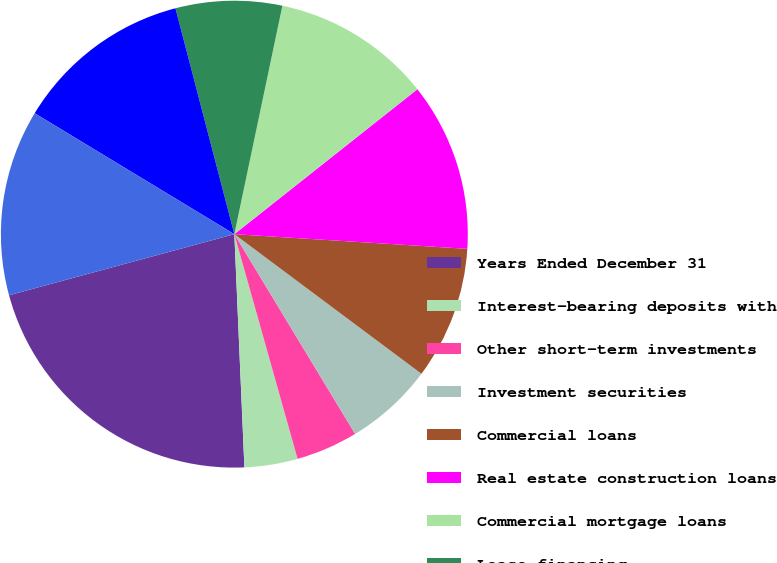Convert chart. <chart><loc_0><loc_0><loc_500><loc_500><pie_chart><fcel>Years Ended December 31<fcel>Interest-bearing deposits with<fcel>Other short-term investments<fcel>Investment securities<fcel>Commercial loans<fcel>Real estate construction loans<fcel>Commercial mortgage loans<fcel>Lease financing<fcel>International loans<fcel>Residential mortgage loans<nl><fcel>21.47%<fcel>3.68%<fcel>4.29%<fcel>6.14%<fcel>9.2%<fcel>11.66%<fcel>11.04%<fcel>7.36%<fcel>12.27%<fcel>12.88%<nl></chart> 